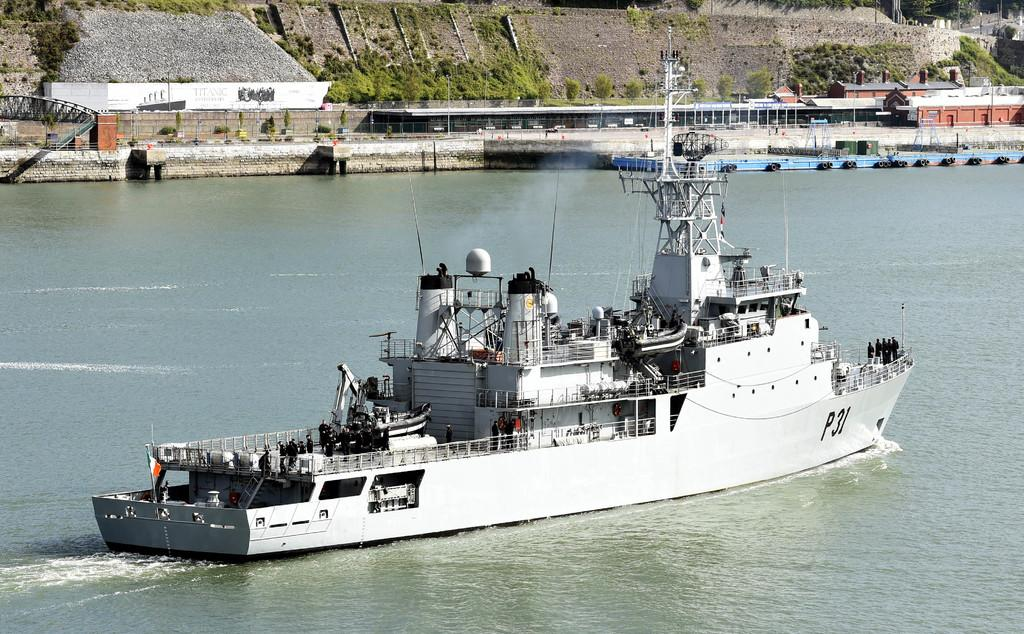What is the main subject of the image? The main subject of the image is a ship. Where is the ship located? The ship is on the water. What can be seen in the background of the image? In the background of the image, there is a building, a wall, a fence, grass, trees, a pole, and a shed. Can you see a playground in the image? No, there is no playground present in the image. Is there a wren perched on the ship in the image? No, there is no wren visible in the image. 